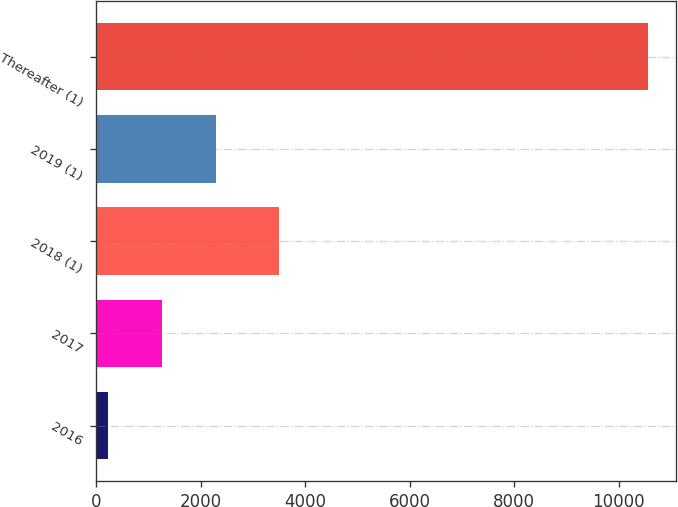<chart> <loc_0><loc_0><loc_500><loc_500><bar_chart><fcel>2016<fcel>2017<fcel>2018 (1)<fcel>2019 (1)<fcel>Thereafter (1)<nl><fcel>227<fcel>1260.7<fcel>3493<fcel>2294.4<fcel>10564<nl></chart> 